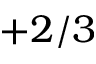<formula> <loc_0><loc_0><loc_500><loc_500>+ 2 / 3</formula> 